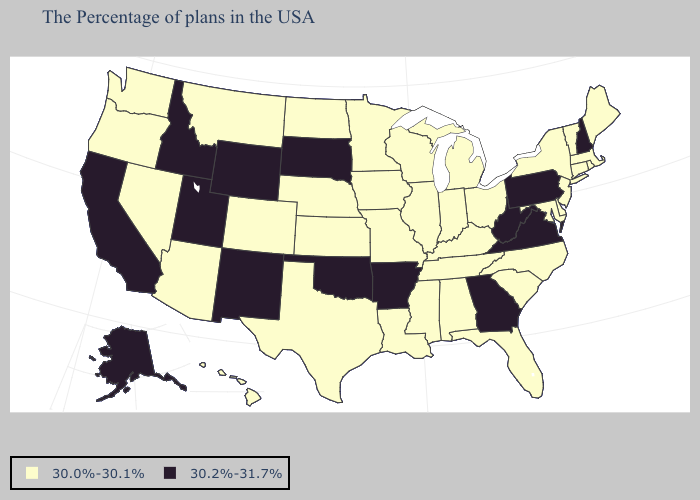Name the states that have a value in the range 30.0%-30.1%?
Short answer required. Maine, Massachusetts, Rhode Island, Vermont, Connecticut, New York, New Jersey, Delaware, Maryland, North Carolina, South Carolina, Ohio, Florida, Michigan, Kentucky, Indiana, Alabama, Tennessee, Wisconsin, Illinois, Mississippi, Louisiana, Missouri, Minnesota, Iowa, Kansas, Nebraska, Texas, North Dakota, Colorado, Montana, Arizona, Nevada, Washington, Oregon, Hawaii. Name the states that have a value in the range 30.2%-31.7%?
Give a very brief answer. New Hampshire, Pennsylvania, Virginia, West Virginia, Georgia, Arkansas, Oklahoma, South Dakota, Wyoming, New Mexico, Utah, Idaho, California, Alaska. What is the lowest value in the Northeast?
Write a very short answer. 30.0%-30.1%. What is the value of South Dakota?
Be succinct. 30.2%-31.7%. Does the first symbol in the legend represent the smallest category?
Concise answer only. Yes. Does Alabama have the highest value in the South?
Be succinct. No. What is the value of New Hampshire?
Answer briefly. 30.2%-31.7%. What is the highest value in the USA?
Quick response, please. 30.2%-31.7%. Does Texas have the same value as Georgia?
Keep it brief. No. Name the states that have a value in the range 30.2%-31.7%?
Give a very brief answer. New Hampshire, Pennsylvania, Virginia, West Virginia, Georgia, Arkansas, Oklahoma, South Dakota, Wyoming, New Mexico, Utah, Idaho, California, Alaska. What is the value of Indiana?
Short answer required. 30.0%-30.1%. How many symbols are there in the legend?
Short answer required. 2. How many symbols are there in the legend?
Short answer required. 2. Name the states that have a value in the range 30.0%-30.1%?
Keep it brief. Maine, Massachusetts, Rhode Island, Vermont, Connecticut, New York, New Jersey, Delaware, Maryland, North Carolina, South Carolina, Ohio, Florida, Michigan, Kentucky, Indiana, Alabama, Tennessee, Wisconsin, Illinois, Mississippi, Louisiana, Missouri, Minnesota, Iowa, Kansas, Nebraska, Texas, North Dakota, Colorado, Montana, Arizona, Nevada, Washington, Oregon, Hawaii. Does the first symbol in the legend represent the smallest category?
Quick response, please. Yes. 